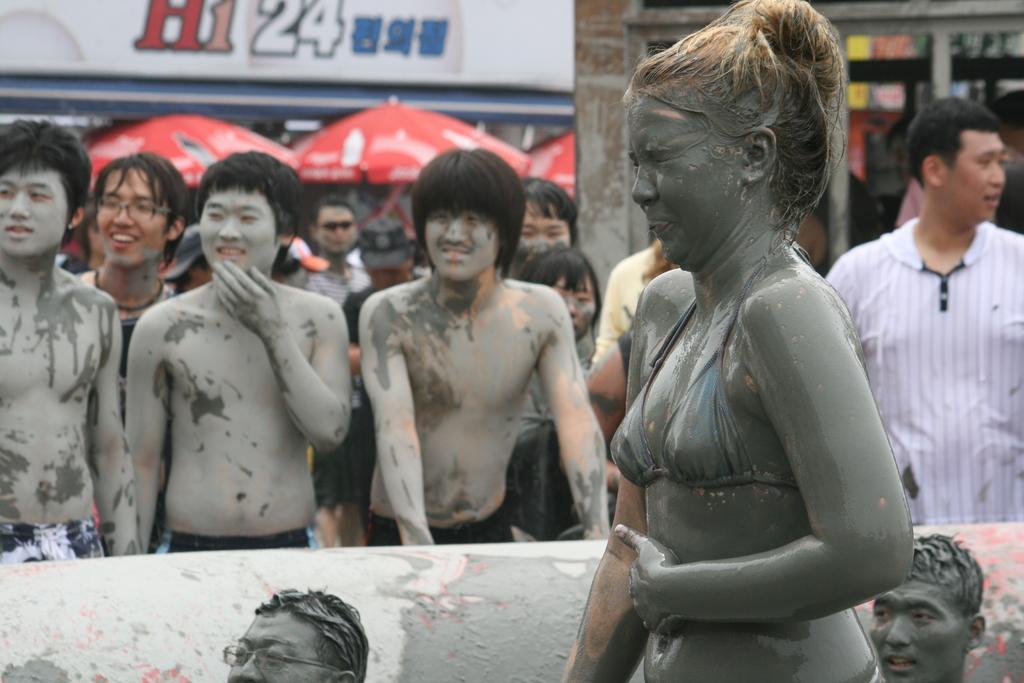How would you summarize this image in a sentence or two? In this image there are few people covered with mud, few other people are there. In the background there are red umbrellas and buildings. In the foreground there is a lady. 